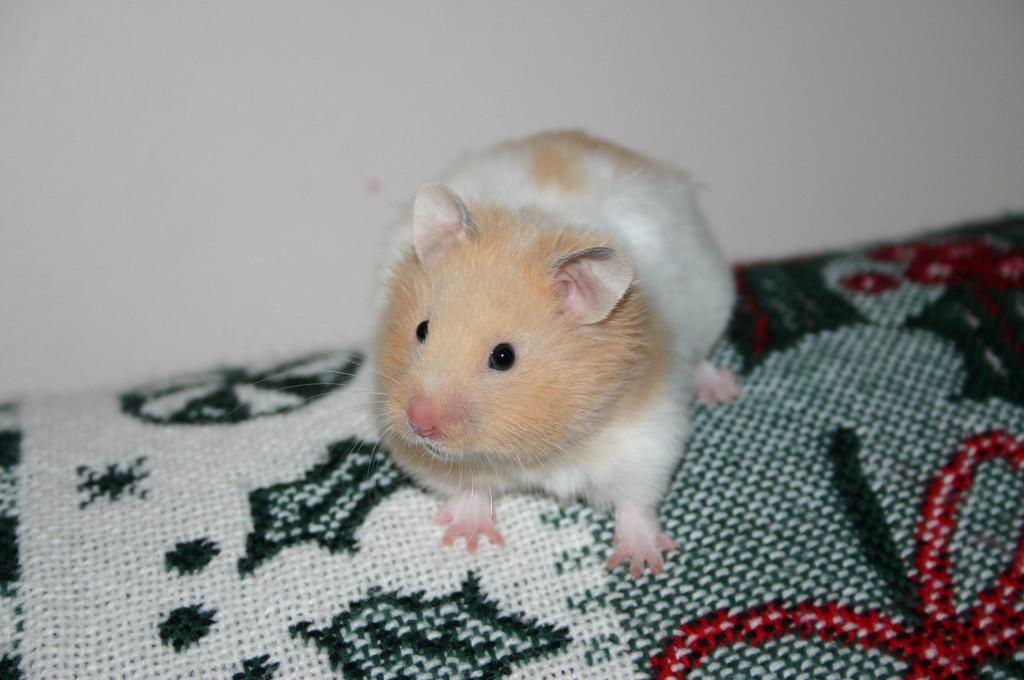Can you describe this image briefly? In this picture, we see the hamster is on the cloth or a carpet which is in white, black and red color. In the background, we see a white wall. This picture might be clicked inside the room. 